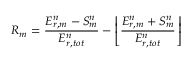<formula> <loc_0><loc_0><loc_500><loc_500>R _ { m } = \frac { E _ { r , m } ^ { n } - S _ { m } ^ { n } } { E _ { r , t o t } ^ { n } } - \left \lfloor \frac { E _ { r , m } ^ { n } + S _ { m } ^ { n } } { E _ { r , t o t } ^ { n } } \right \rfloor</formula> 